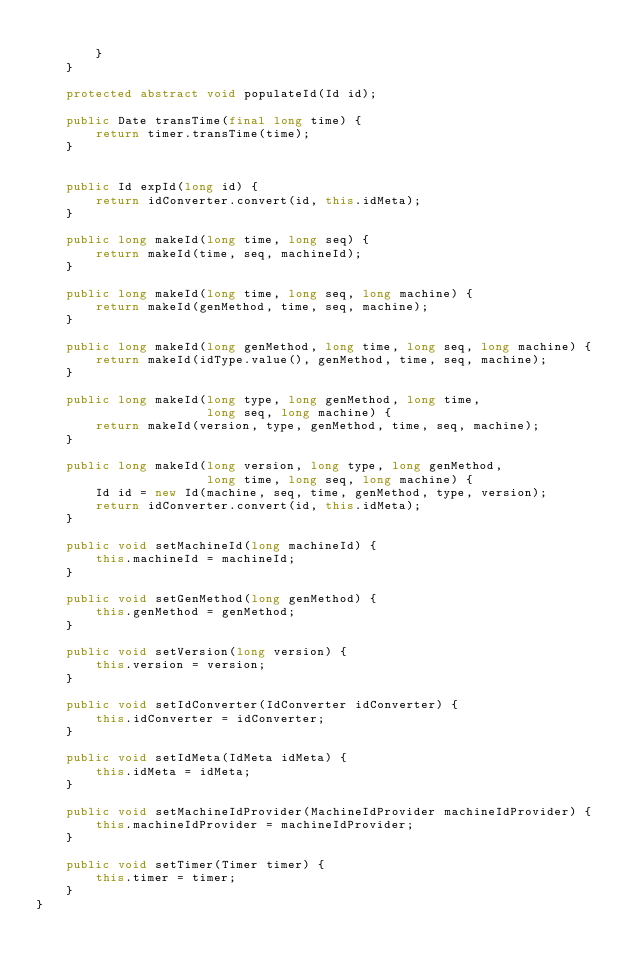<code> <loc_0><loc_0><loc_500><loc_500><_Java_>
        }
    }

    protected abstract void populateId(Id id);

    public Date transTime(final long time) {
        return timer.transTime(time);
    }


    public Id expId(long id) {
        return idConverter.convert(id, this.idMeta);
    }

    public long makeId(long time, long seq) {
        return makeId(time, seq, machineId);
    }

    public long makeId(long time, long seq, long machine) {
        return makeId(genMethod, time, seq, machine);
    }

    public long makeId(long genMethod, long time, long seq, long machine) {
        return makeId(idType.value(), genMethod, time, seq, machine);
    }

    public long makeId(long type, long genMethod, long time,
                       long seq, long machine) {
        return makeId(version, type, genMethod, time, seq, machine);
    }

    public long makeId(long version, long type, long genMethod,
                       long time, long seq, long machine) {
        Id id = new Id(machine, seq, time, genMethod, type, version);
        return idConverter.convert(id, this.idMeta);
    }

    public void setMachineId(long machineId) {
        this.machineId = machineId;
    }

    public void setGenMethod(long genMethod) {
        this.genMethod = genMethod;
    }

    public void setVersion(long version) {
        this.version = version;
    }

    public void setIdConverter(IdConverter idConverter) {
        this.idConverter = idConverter;
    }

    public void setIdMeta(IdMeta idMeta) {
        this.idMeta = idMeta;
    }

    public void setMachineIdProvider(MachineIdProvider machineIdProvider) {
        this.machineIdProvider = machineIdProvider;
    }

    public void setTimer(Timer timer) {
        this.timer = timer;
    }
}</code> 